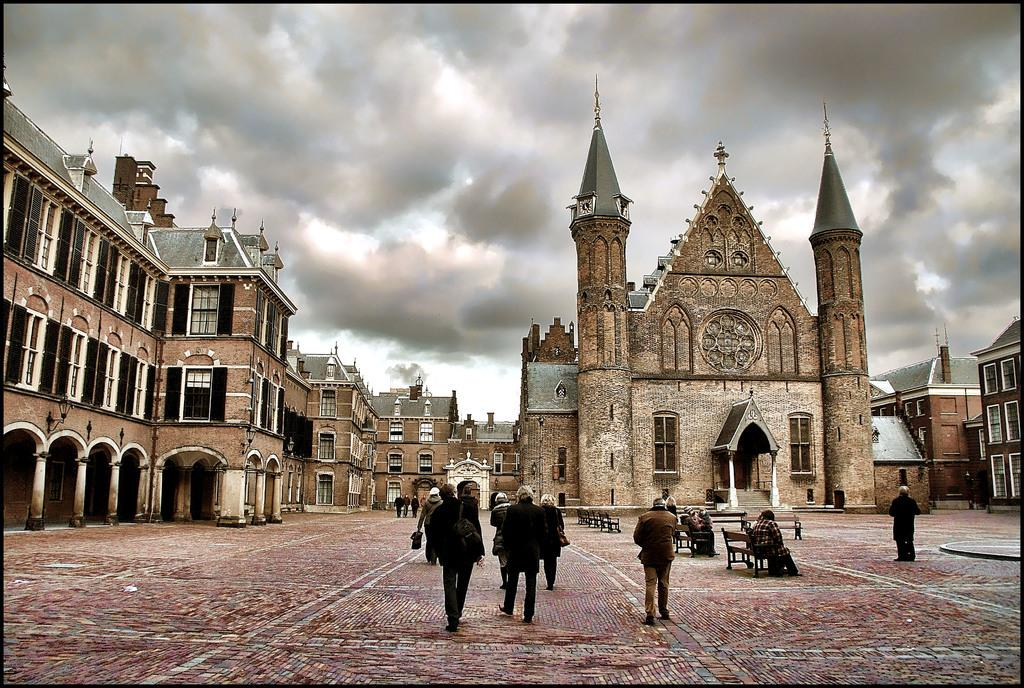What are the people in the image doing? There is a group of people on the ground, and some people are sitting on benches. What can be seen in the background of the image? There are buildings and the sky visible in the background of the image. What type of kettle can be seen on the plate in the image? There is no kettle or plate present in the image. How many yams are visible on the ground in the image? There are no yams visible in the image. 